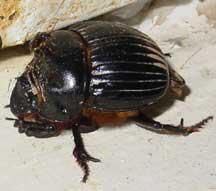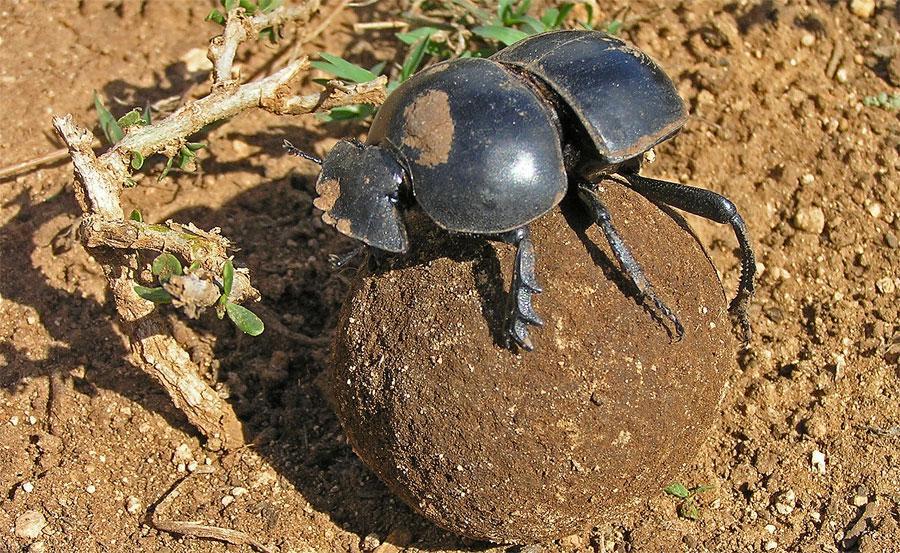The first image is the image on the left, the second image is the image on the right. Analyze the images presented: Is the assertion "there is a ball of dung in the right pic" valid? Answer yes or no. Yes. The first image is the image on the left, the second image is the image on the right. Assess this claim about the two images: "A beetle is pictured with a ball of dug.". Correct or not? Answer yes or no. Yes. 